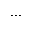<formula> <loc_0><loc_0><loc_500><loc_500>\dots</formula> 